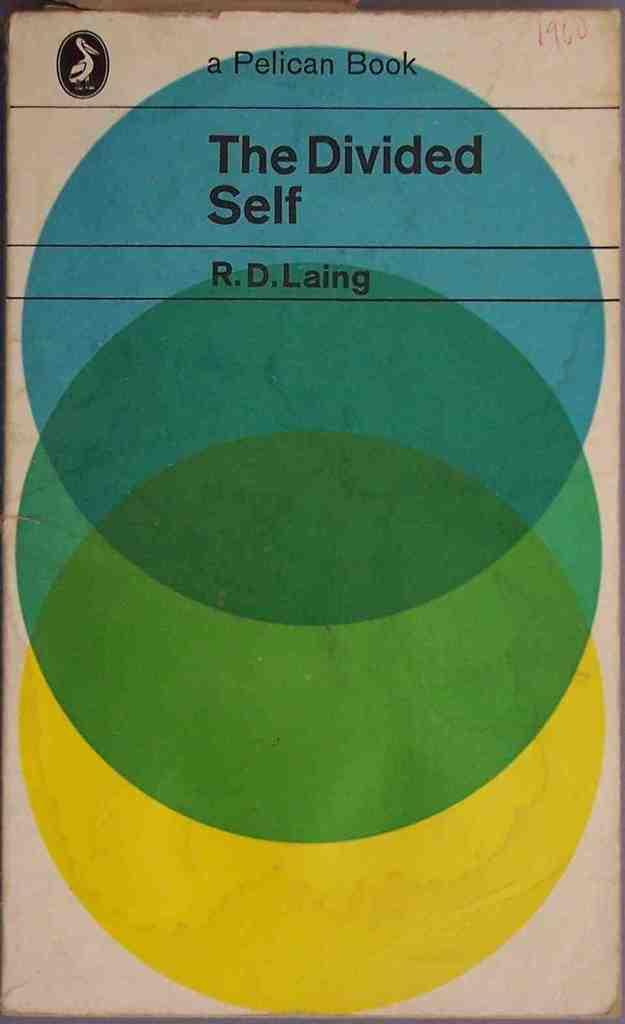What object is present in the image? There is a book in the image. What can be found on the book? The book has text on it and color circles. What committee is responsible for the book in the image? There is no committee mentioned or implied in the image, as it only shows a book with text and color circles. 